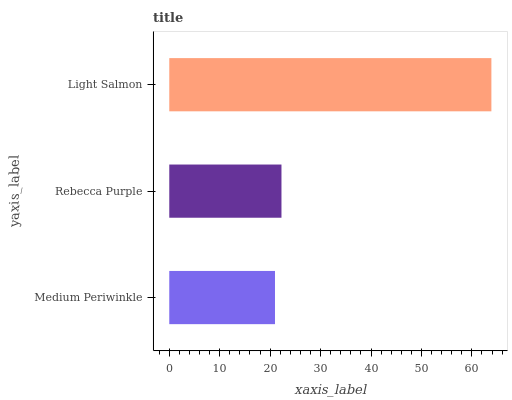Is Medium Periwinkle the minimum?
Answer yes or no. Yes. Is Light Salmon the maximum?
Answer yes or no. Yes. Is Rebecca Purple the minimum?
Answer yes or no. No. Is Rebecca Purple the maximum?
Answer yes or no. No. Is Rebecca Purple greater than Medium Periwinkle?
Answer yes or no. Yes. Is Medium Periwinkle less than Rebecca Purple?
Answer yes or no. Yes. Is Medium Periwinkle greater than Rebecca Purple?
Answer yes or no. No. Is Rebecca Purple less than Medium Periwinkle?
Answer yes or no. No. Is Rebecca Purple the high median?
Answer yes or no. Yes. Is Rebecca Purple the low median?
Answer yes or no. Yes. Is Medium Periwinkle the high median?
Answer yes or no. No. Is Medium Periwinkle the low median?
Answer yes or no. No. 